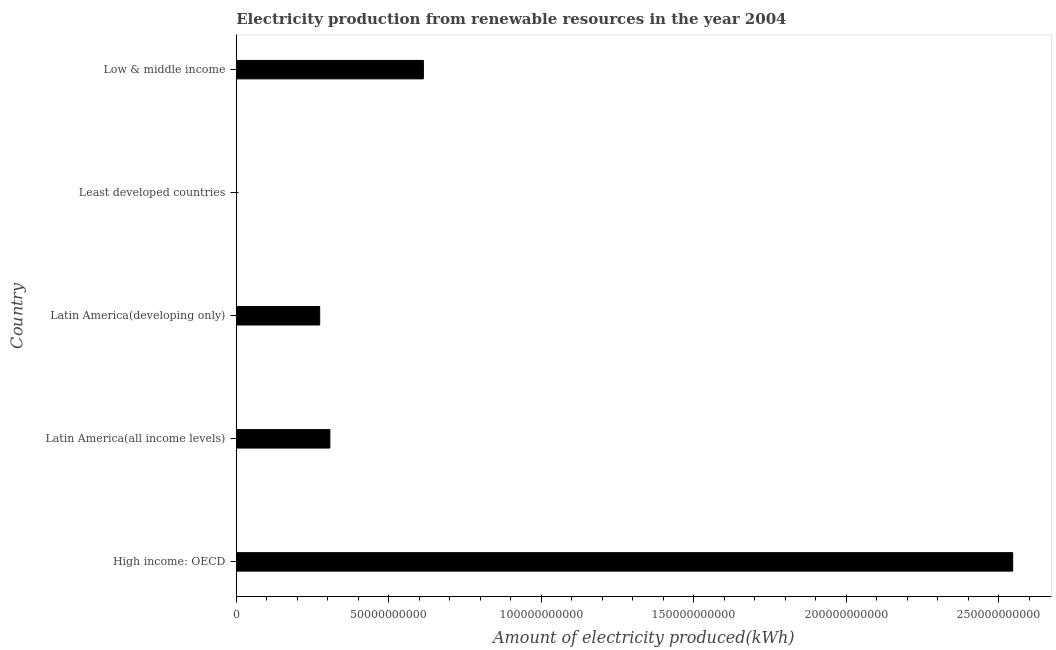Does the graph contain grids?
Your answer should be compact. No. What is the title of the graph?
Your response must be concise. Electricity production from renewable resources in the year 2004. What is the label or title of the X-axis?
Offer a very short reply. Amount of electricity produced(kWh). What is the label or title of the Y-axis?
Ensure brevity in your answer.  Country. What is the amount of electricity produced in High income: OECD?
Your response must be concise. 2.55e+11. Across all countries, what is the maximum amount of electricity produced?
Provide a succinct answer. 2.55e+11. Across all countries, what is the minimum amount of electricity produced?
Your answer should be very brief. 6.20e+07. In which country was the amount of electricity produced maximum?
Give a very brief answer. High income: OECD. In which country was the amount of electricity produced minimum?
Give a very brief answer. Least developed countries. What is the sum of the amount of electricity produced?
Your response must be concise. 3.74e+11. What is the difference between the amount of electricity produced in Latin America(all income levels) and Low & middle income?
Make the answer very short. -3.07e+1. What is the average amount of electricity produced per country?
Give a very brief answer. 7.48e+1. What is the median amount of electricity produced?
Your answer should be very brief. 3.07e+1. What is the ratio of the amount of electricity produced in High income: OECD to that in Latin America(all income levels)?
Give a very brief answer. 8.29. What is the difference between the highest and the second highest amount of electricity produced?
Ensure brevity in your answer.  1.93e+11. Is the sum of the amount of electricity produced in Latin America(developing only) and Low & middle income greater than the maximum amount of electricity produced across all countries?
Your answer should be compact. No. What is the difference between the highest and the lowest amount of electricity produced?
Offer a very short reply. 2.55e+11. Are all the bars in the graph horizontal?
Offer a very short reply. Yes. How many countries are there in the graph?
Provide a short and direct response. 5. What is the difference between two consecutive major ticks on the X-axis?
Your answer should be very brief. 5.00e+1. What is the Amount of electricity produced(kWh) in High income: OECD?
Make the answer very short. 2.55e+11. What is the Amount of electricity produced(kWh) in Latin America(all income levels)?
Ensure brevity in your answer.  3.07e+1. What is the Amount of electricity produced(kWh) in Latin America(developing only)?
Offer a very short reply. 2.74e+1. What is the Amount of electricity produced(kWh) of Least developed countries?
Your response must be concise. 6.20e+07. What is the Amount of electricity produced(kWh) of Low & middle income?
Your response must be concise. 6.14e+1. What is the difference between the Amount of electricity produced(kWh) in High income: OECD and Latin America(all income levels)?
Your answer should be compact. 2.24e+11. What is the difference between the Amount of electricity produced(kWh) in High income: OECD and Latin America(developing only)?
Your response must be concise. 2.27e+11. What is the difference between the Amount of electricity produced(kWh) in High income: OECD and Least developed countries?
Ensure brevity in your answer.  2.55e+11. What is the difference between the Amount of electricity produced(kWh) in High income: OECD and Low & middle income?
Keep it short and to the point. 1.93e+11. What is the difference between the Amount of electricity produced(kWh) in Latin America(all income levels) and Latin America(developing only)?
Offer a very short reply. 3.34e+09. What is the difference between the Amount of electricity produced(kWh) in Latin America(all income levels) and Least developed countries?
Provide a succinct answer. 3.06e+1. What is the difference between the Amount of electricity produced(kWh) in Latin America(all income levels) and Low & middle income?
Provide a succinct answer. -3.07e+1. What is the difference between the Amount of electricity produced(kWh) in Latin America(developing only) and Least developed countries?
Your answer should be very brief. 2.73e+1. What is the difference between the Amount of electricity produced(kWh) in Latin America(developing only) and Low & middle income?
Your answer should be very brief. -3.40e+1. What is the difference between the Amount of electricity produced(kWh) in Least developed countries and Low & middle income?
Keep it short and to the point. -6.13e+1. What is the ratio of the Amount of electricity produced(kWh) in High income: OECD to that in Latin America(all income levels)?
Keep it short and to the point. 8.29. What is the ratio of the Amount of electricity produced(kWh) in High income: OECD to that in Latin America(developing only)?
Your response must be concise. 9.31. What is the ratio of the Amount of electricity produced(kWh) in High income: OECD to that in Least developed countries?
Your answer should be compact. 4106.79. What is the ratio of the Amount of electricity produced(kWh) in High income: OECD to that in Low & middle income?
Ensure brevity in your answer.  4.15. What is the ratio of the Amount of electricity produced(kWh) in Latin America(all income levels) to that in Latin America(developing only)?
Your answer should be very brief. 1.12. What is the ratio of the Amount of electricity produced(kWh) in Latin America(all income levels) to that in Least developed countries?
Make the answer very short. 495.21. What is the ratio of the Amount of electricity produced(kWh) in Latin America(all income levels) to that in Low & middle income?
Ensure brevity in your answer.  0.5. What is the ratio of the Amount of electricity produced(kWh) in Latin America(developing only) to that in Least developed countries?
Provide a short and direct response. 441.27. What is the ratio of the Amount of electricity produced(kWh) in Latin America(developing only) to that in Low & middle income?
Give a very brief answer. 0.45. What is the ratio of the Amount of electricity produced(kWh) in Least developed countries to that in Low & middle income?
Your answer should be compact. 0. 